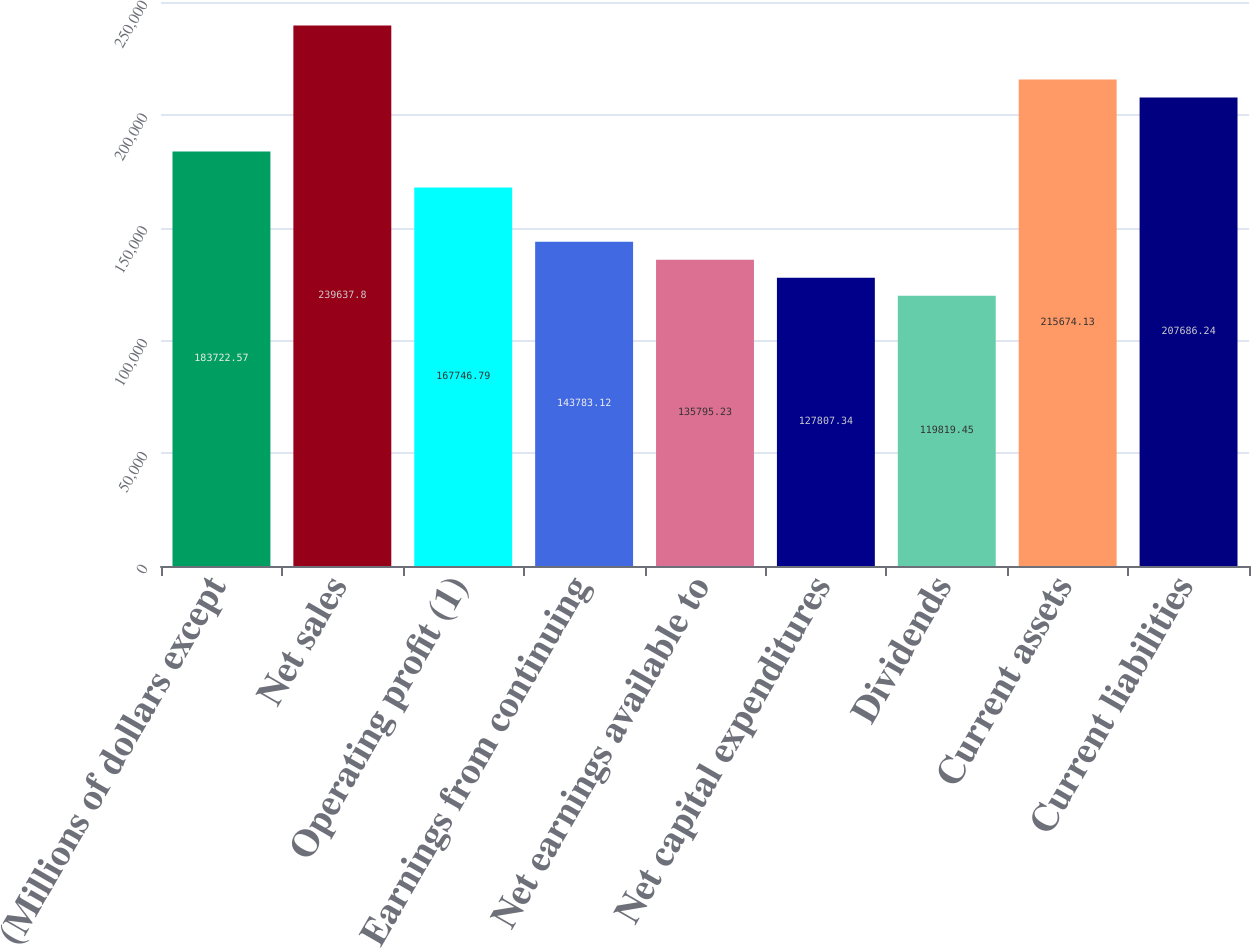Convert chart. <chart><loc_0><loc_0><loc_500><loc_500><bar_chart><fcel>(Millions of dollars except<fcel>Net sales<fcel>Operating profit (1)<fcel>Earnings from continuing<fcel>Net earnings available to<fcel>Net capital expenditures<fcel>Dividends<fcel>Current assets<fcel>Current liabilities<nl><fcel>183723<fcel>239638<fcel>167747<fcel>143783<fcel>135795<fcel>127807<fcel>119819<fcel>215674<fcel>207686<nl></chart> 